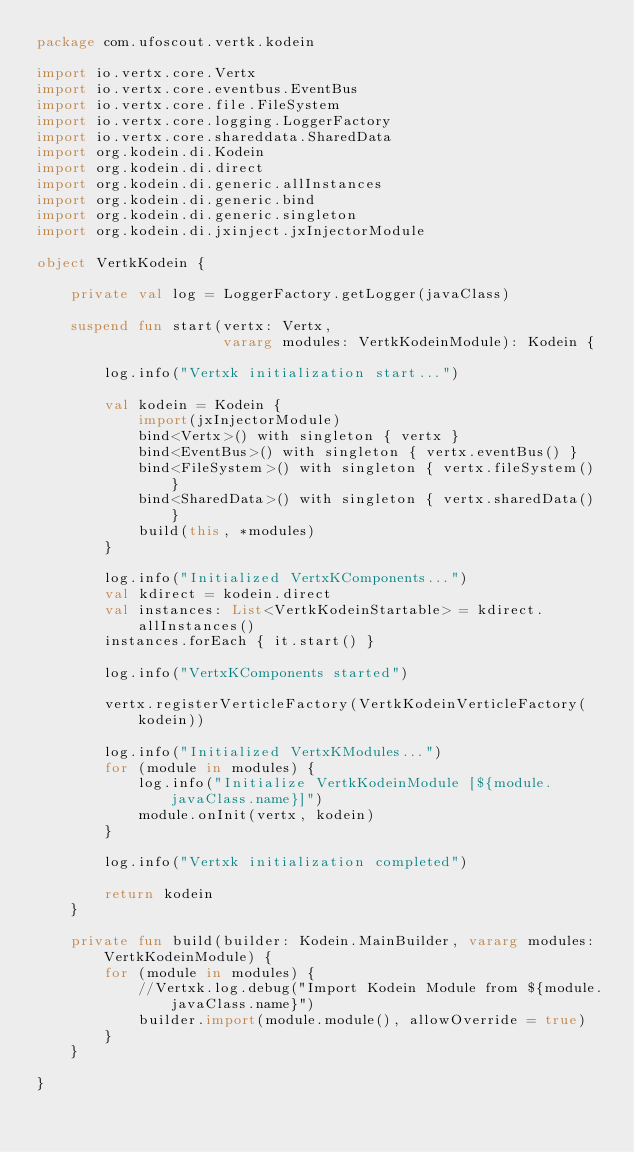<code> <loc_0><loc_0><loc_500><loc_500><_Kotlin_>package com.ufoscout.vertk.kodein

import io.vertx.core.Vertx
import io.vertx.core.eventbus.EventBus
import io.vertx.core.file.FileSystem
import io.vertx.core.logging.LoggerFactory
import io.vertx.core.shareddata.SharedData
import org.kodein.di.Kodein
import org.kodein.di.direct
import org.kodein.di.generic.allInstances
import org.kodein.di.generic.bind
import org.kodein.di.generic.singleton
import org.kodein.di.jxinject.jxInjectorModule

object VertkKodein {

    private val log = LoggerFactory.getLogger(javaClass)

    suspend fun start(vertx: Vertx,
                      vararg modules: VertkKodeinModule): Kodein {

        log.info("Vertxk initialization start...")

        val kodein = Kodein {
            import(jxInjectorModule)
            bind<Vertx>() with singleton { vertx }
            bind<EventBus>() with singleton { vertx.eventBus() }
            bind<FileSystem>() with singleton { vertx.fileSystem() }
            bind<SharedData>() with singleton { vertx.sharedData() }
            build(this, *modules)
        }

        log.info("Initialized VertxKComponents...")
        val kdirect = kodein.direct
        val instances: List<VertkKodeinStartable> = kdirect.allInstances()
        instances.forEach { it.start() }

        log.info("VertxKComponents started")

        vertx.registerVerticleFactory(VertkKodeinVerticleFactory(kodein))

        log.info("Initialized VertxKModules...")
        for (module in modules) {
            log.info("Initialize VertkKodeinModule [${module.javaClass.name}]")
            module.onInit(vertx, kodein)
        }

        log.info("Vertxk initialization completed")

        return kodein
    }

    private fun build(builder: Kodein.MainBuilder, vararg modules: VertkKodeinModule) {
        for (module in modules) {
            //Vertxk.log.debug("Import Kodein Module from ${module.javaClass.name}")
            builder.import(module.module(), allowOverride = true)
        }
    }

}</code> 